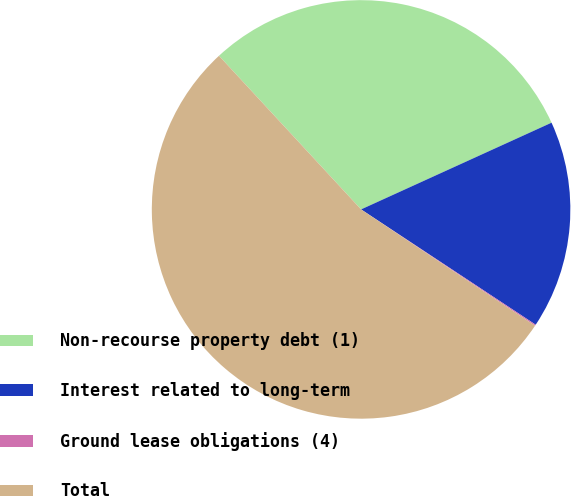<chart> <loc_0><loc_0><loc_500><loc_500><pie_chart><fcel>Non-recourse property debt (1)<fcel>Interest related to long-term<fcel>Ground lease obligations (4)<fcel>Total<nl><fcel>30.08%<fcel>16.09%<fcel>0.09%<fcel>53.74%<nl></chart> 